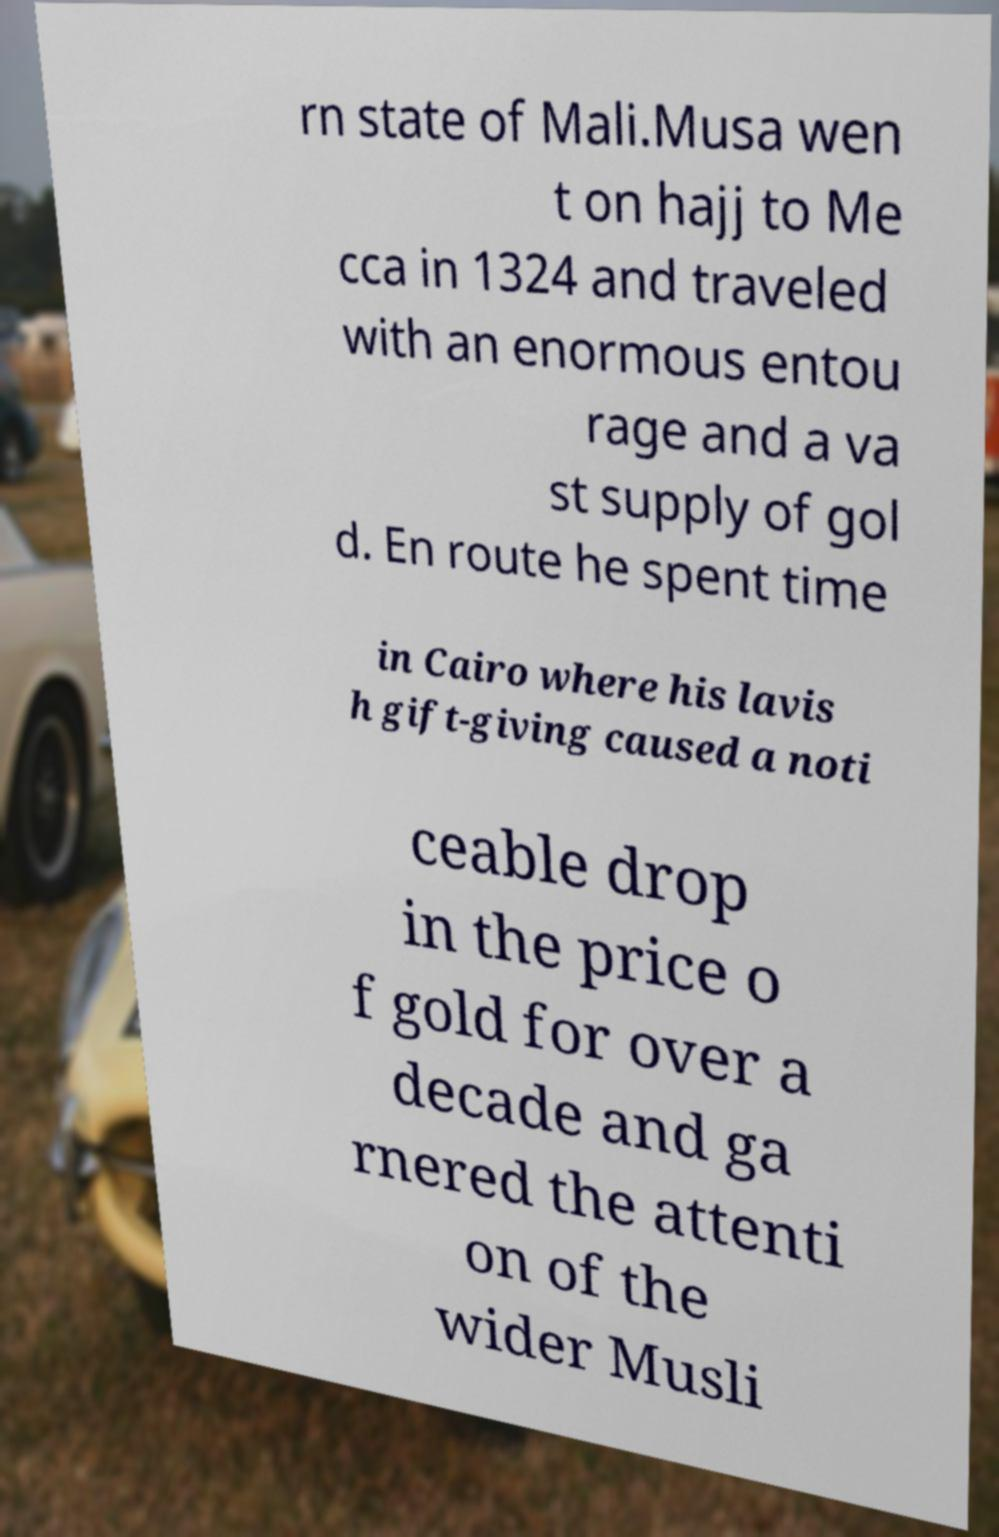Can you accurately transcribe the text from the provided image for me? rn state of Mali.Musa wen t on hajj to Me cca in 1324 and traveled with an enormous entou rage and a va st supply of gol d. En route he spent time in Cairo where his lavis h gift-giving caused a noti ceable drop in the price o f gold for over a decade and ga rnered the attenti on of the wider Musli 